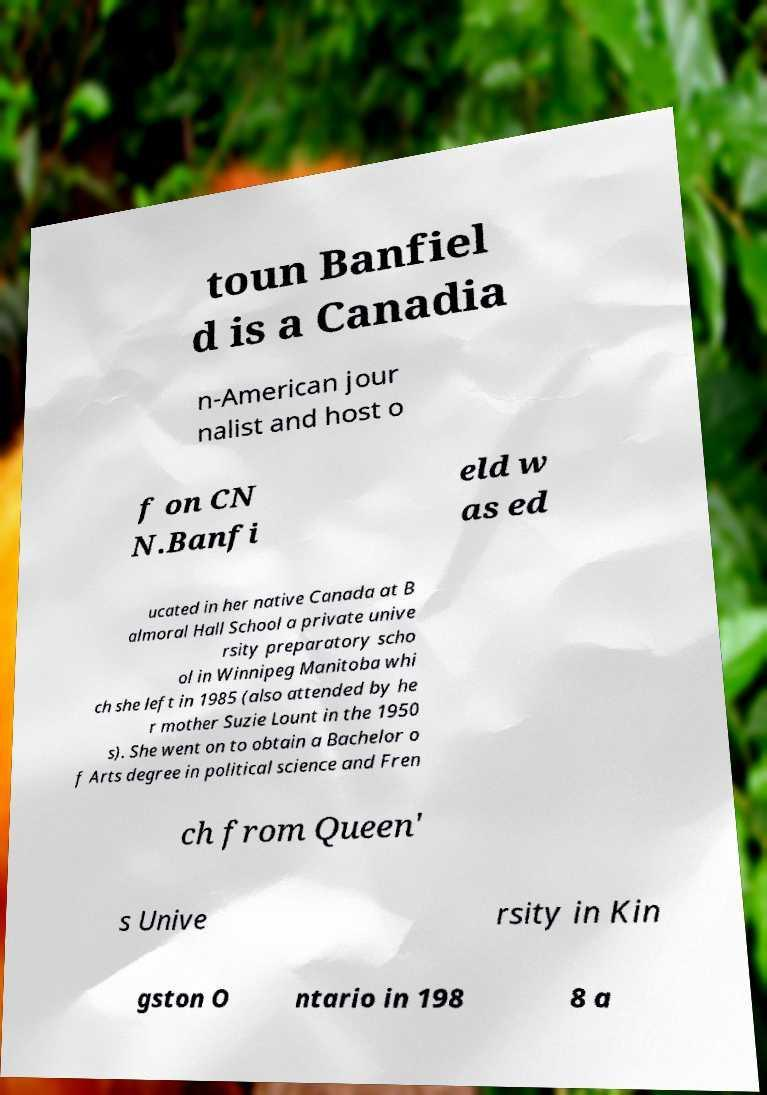Can you read and provide the text displayed in the image?This photo seems to have some interesting text. Can you extract and type it out for me? toun Banfiel d is a Canadia n-American jour nalist and host o f on CN N.Banfi eld w as ed ucated in her native Canada at B almoral Hall School a private unive rsity preparatory scho ol in Winnipeg Manitoba whi ch she left in 1985 (also attended by he r mother Suzie Lount in the 1950 s). She went on to obtain a Bachelor o f Arts degree in political science and Fren ch from Queen' s Unive rsity in Kin gston O ntario in 198 8 a 